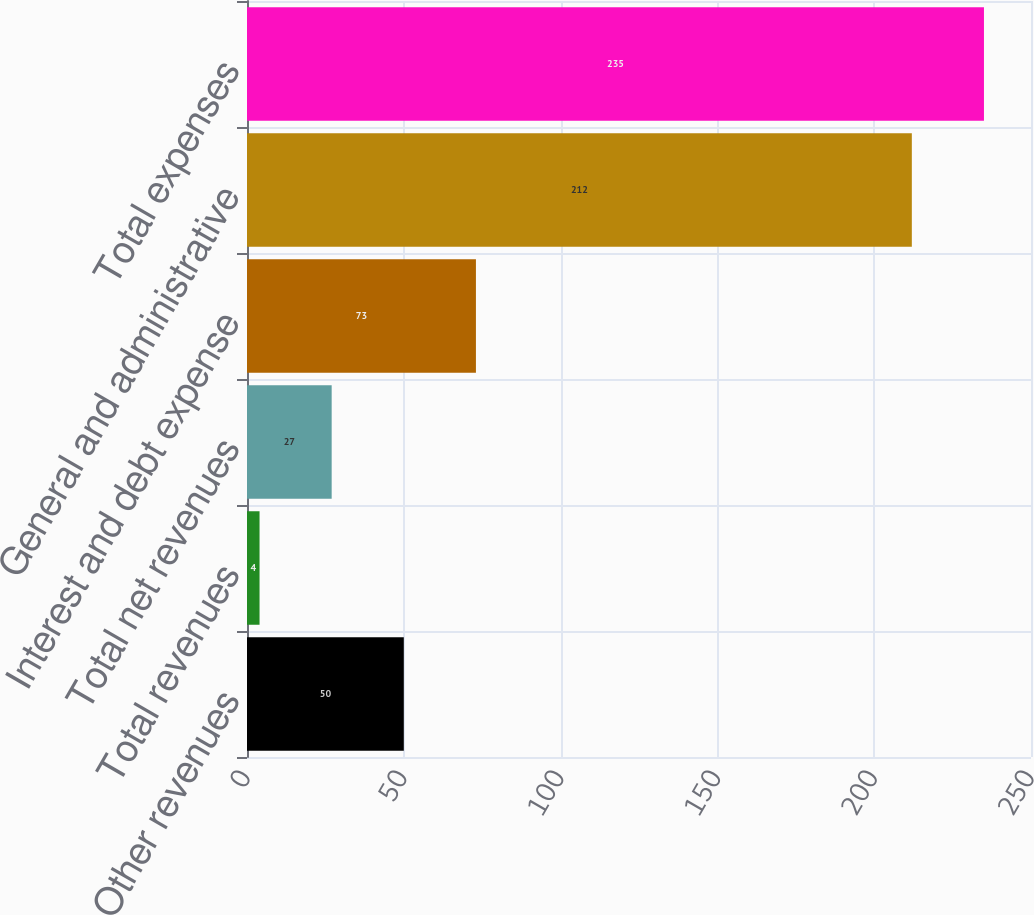<chart> <loc_0><loc_0><loc_500><loc_500><bar_chart><fcel>Other revenues<fcel>Total revenues<fcel>Total net revenues<fcel>Interest and debt expense<fcel>General and administrative<fcel>Total expenses<nl><fcel>50<fcel>4<fcel>27<fcel>73<fcel>212<fcel>235<nl></chart> 